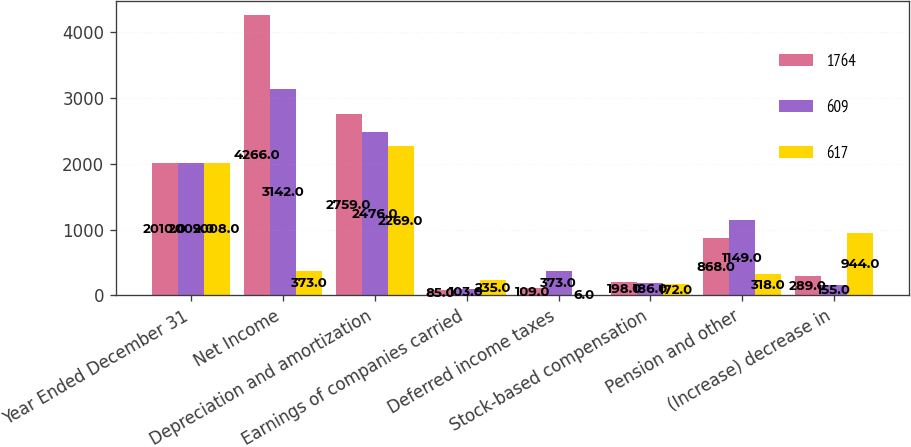Convert chart. <chart><loc_0><loc_0><loc_500><loc_500><stacked_bar_chart><ecel><fcel>Year Ended December 31<fcel>Net Income<fcel>Depreciation and amortization<fcel>Earnings of companies carried<fcel>Deferred income taxes<fcel>Stock-based compensation<fcel>Pension and other<fcel>(Increase) decrease in<nl><fcel>1764<fcel>2010<fcel>4266<fcel>2759<fcel>85<fcel>109<fcel>198<fcel>868<fcel>289<nl><fcel>609<fcel>2009<fcel>3142<fcel>2476<fcel>103<fcel>373<fcel>186<fcel>1149<fcel>155<nl><fcel>617<fcel>2008<fcel>373<fcel>2269<fcel>235<fcel>6<fcel>172<fcel>318<fcel>944<nl></chart> 